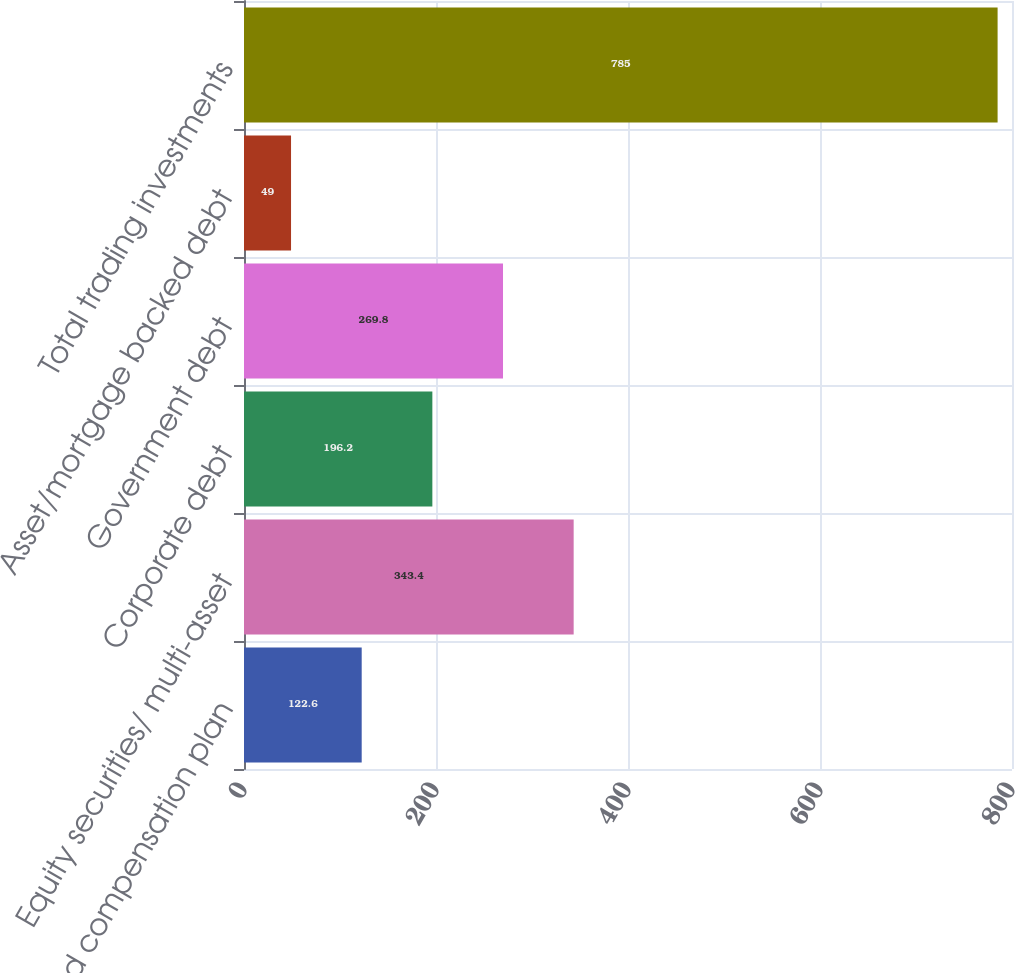Convert chart to OTSL. <chart><loc_0><loc_0><loc_500><loc_500><bar_chart><fcel>Deferred compensation plan<fcel>Equity securities/ multi-asset<fcel>Corporate debt<fcel>Government debt<fcel>Asset/mortgage backed debt<fcel>Total trading investments<nl><fcel>122.6<fcel>343.4<fcel>196.2<fcel>269.8<fcel>49<fcel>785<nl></chart> 